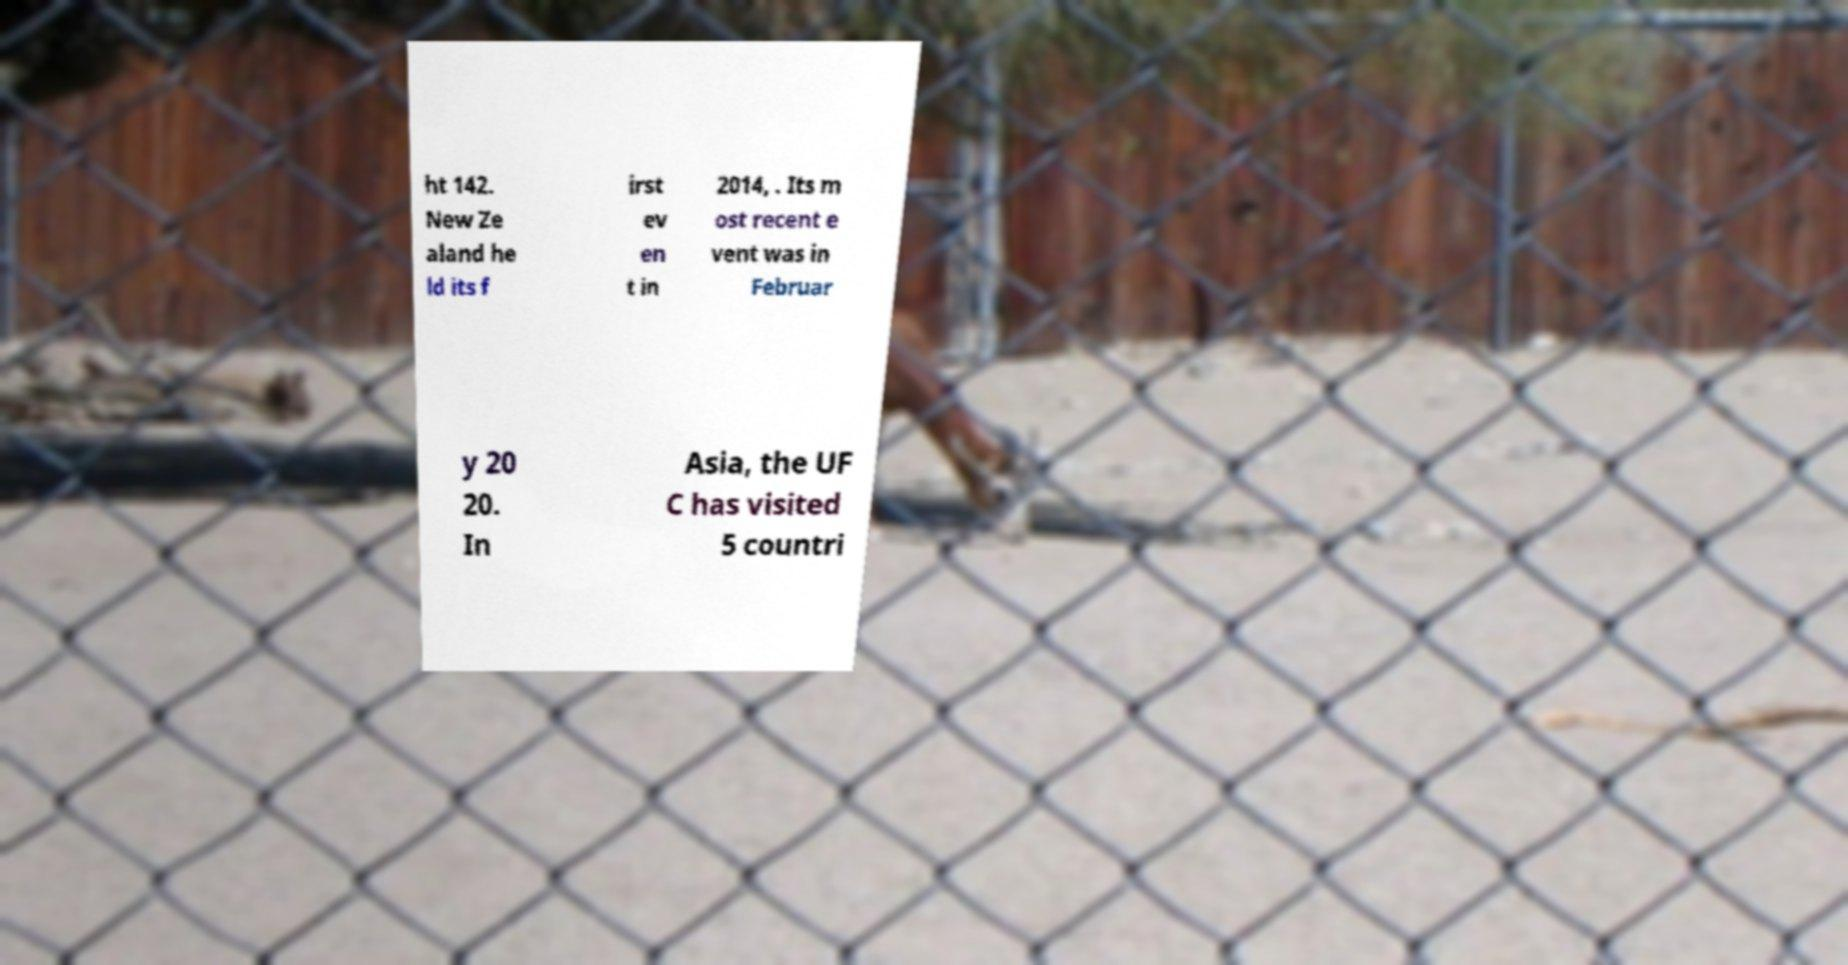Can you accurately transcribe the text from the provided image for me? ht 142. New Ze aland he ld its f irst ev en t in 2014, . Its m ost recent e vent was in Februar y 20 20. In Asia, the UF C has visited 5 countri 